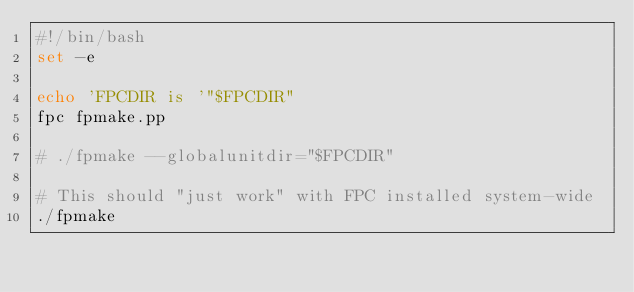Convert code to text. <code><loc_0><loc_0><loc_500><loc_500><_Bash_>#!/bin/bash
set -e

echo 'FPCDIR is '"$FPCDIR"
fpc fpmake.pp

# ./fpmake --globalunitdir="$FPCDIR"

# This should "just work" with FPC installed system-wide
./fpmake
</code> 